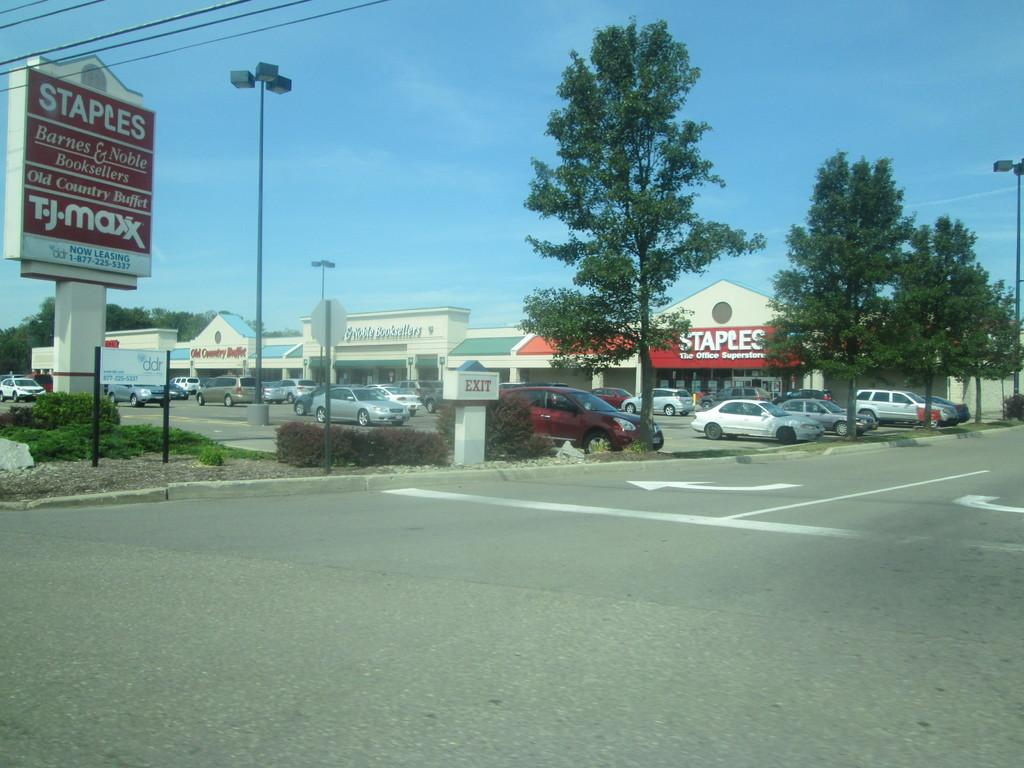What type of natural elements can be seen in the image? There are trees and plants visible in the image. What man-made structures are present in the image? There are poles, name boards, houses, and a road with white lines in the image. What type of transportation is depicted in the image? There are vehicles in the image. What is visible in the background of the image? The background of the image includes the sky and wires. What type of wrist accessory is visible on the trees in the image? There are no wrist accessories present on the trees in the image. What type of straw is used to decorate the vehicles in the image? There are no straws used to decorate the vehicles in the image. 